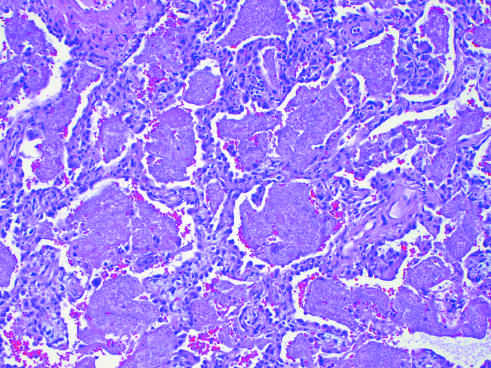re the pattern of staining of anti-centromere antibodies filled with a characteristic foamy acellular exudate?
Answer the question using a single word or phrase. No 